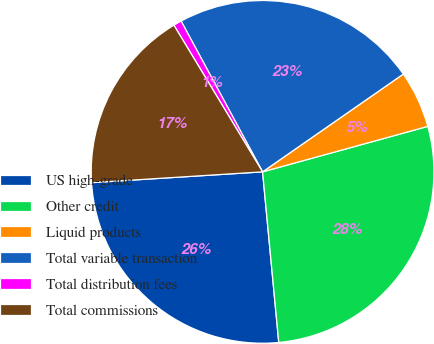<chart> <loc_0><loc_0><loc_500><loc_500><pie_chart><fcel>US high-grade<fcel>Other credit<fcel>Liquid products<fcel>Total variable transaction<fcel>Total distribution fees<fcel>Total commissions<nl><fcel>25.5%<fcel>27.77%<fcel>5.39%<fcel>23.22%<fcel>0.77%<fcel>17.35%<nl></chart> 